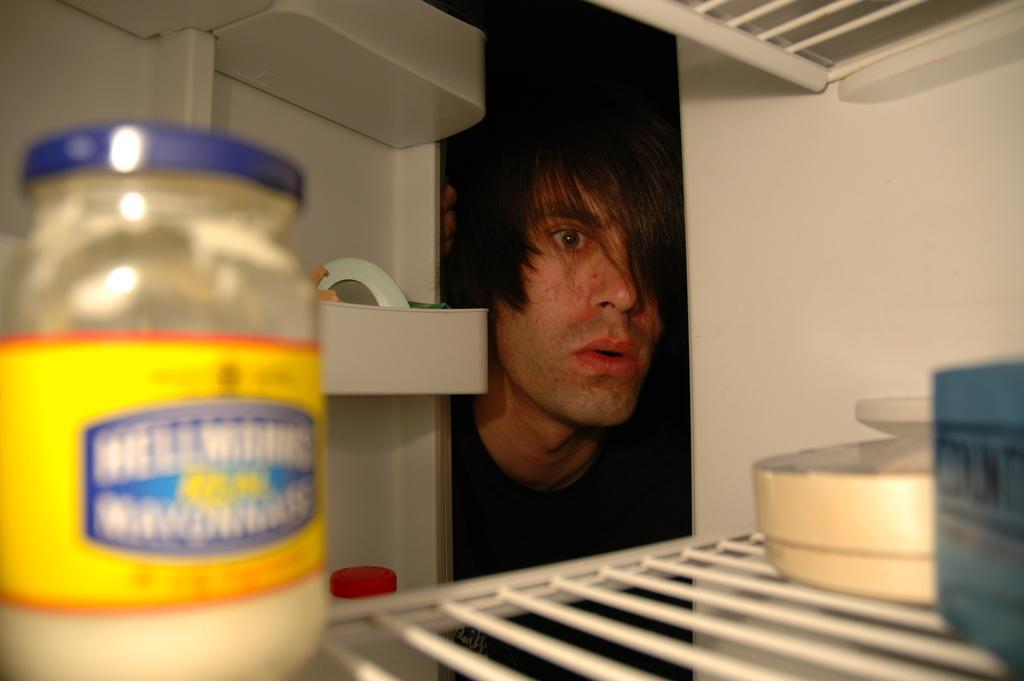In one or two sentences, can you explain what this image depicts? In this picture we can see a person, here we can see a shelf, tin and some objects. 